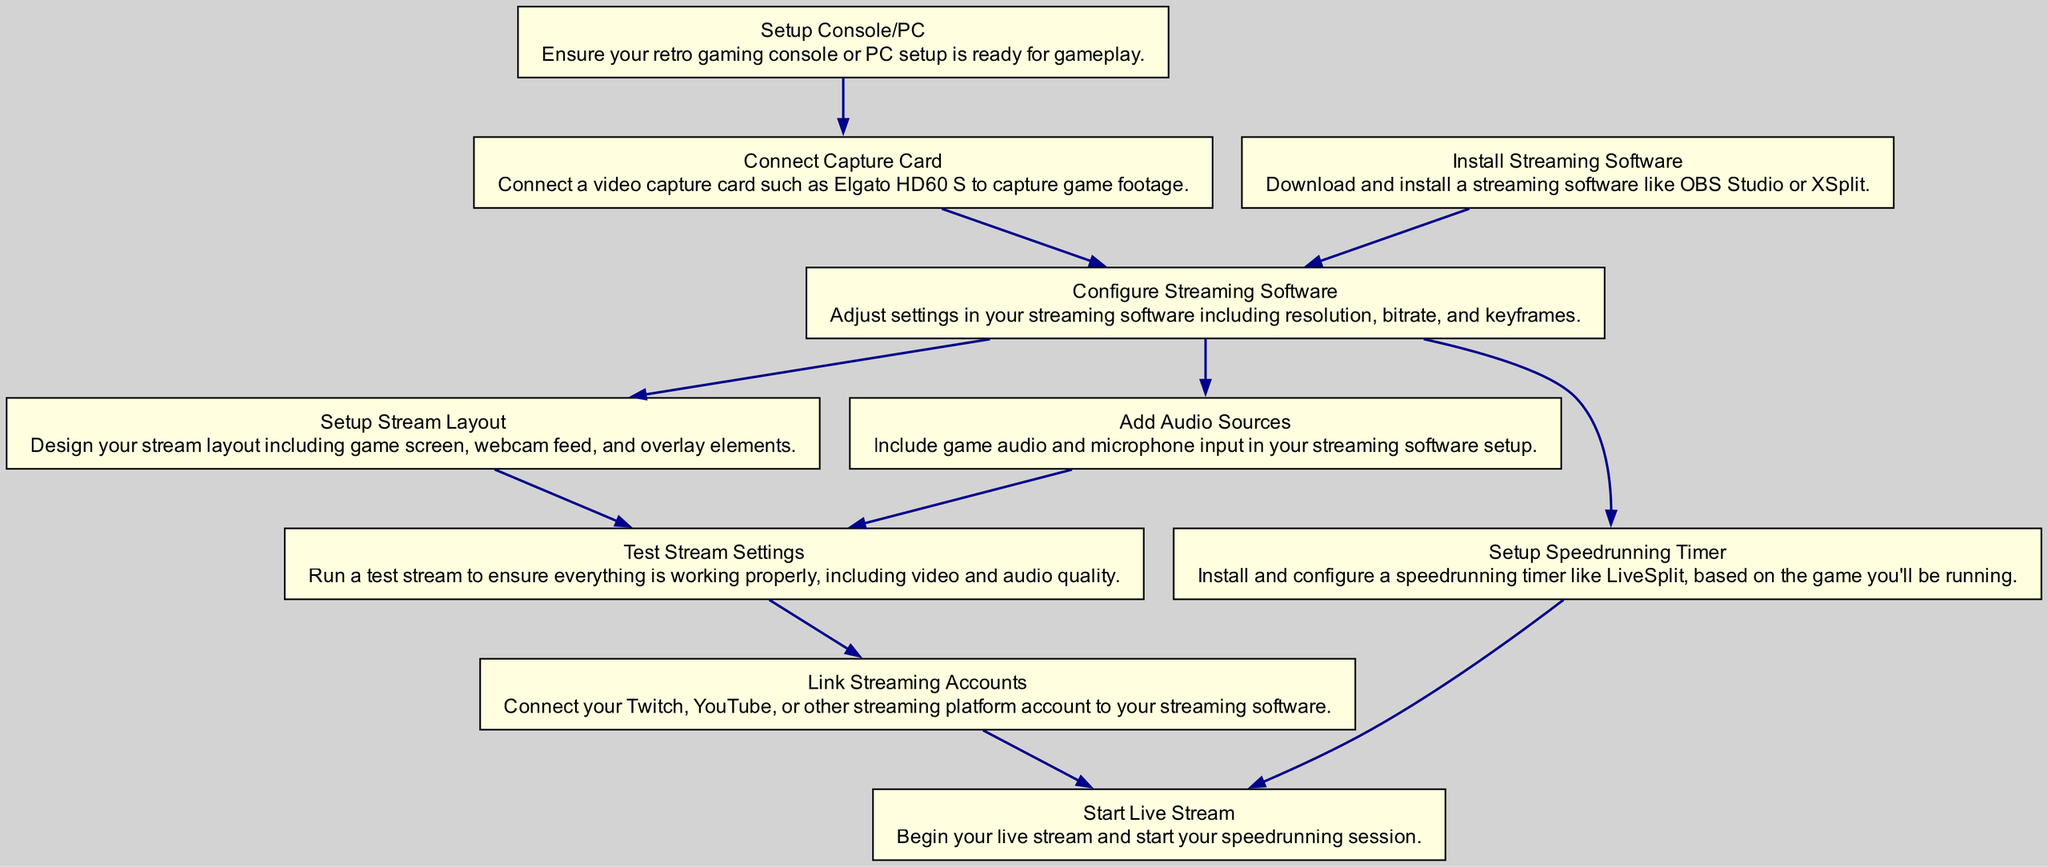What is the first step in setting up a live speedrunning stream? The first step is "Setup Console/PC", as it has no dependencies and is the starting point of the process.
Answer: Setup Console/PC How many steps are there in the setup process? By counting the steps listed in the diagram, there are a total of 10 steps.
Answer: 10 What is the last step in the process? The last step is "Start Live Stream", as it concludes the setup after all prior steps are completed.
Answer: Start Live Stream Which step depends on "Configure Streaming Software"? The steps "Setup Speedrunning Timer" and "Setup Stream Layout" depend on "Configure Streaming Software".
Answer: Setup Speedrunning Timer, Setup Stream Layout What step comes before "Link Streaming Accounts"? The step that comes before "Link Streaming Accounts" is "Test Stream Settings", which must be completed first.
Answer: Test Stream Settings Which step has the most dependencies? The step "Start Live Stream" has the most dependencies, requiring both "Link Streaming Accounts" and "Setup Speedrunning Timer".
Answer: Start Live Stream How many dependencies does "Add Audio Sources" have? "Add Audio Sources" has one dependency, which is "Configure Streaming Software".
Answer: 1 What is the function of "Setup Stream Layout"? "Setup Stream Layout" is responsible for designing your stream layout with elements like the game screen and webcam feed.
Answer: Designing stream layout Is "Connect Capture Card" a prerequisite for testing stream settings? Yes, "Connect Capture Card" is a prerequisite since "Configure Streaming Software," the step it depends on, is also required before testing the stream.
Answer: Yes 